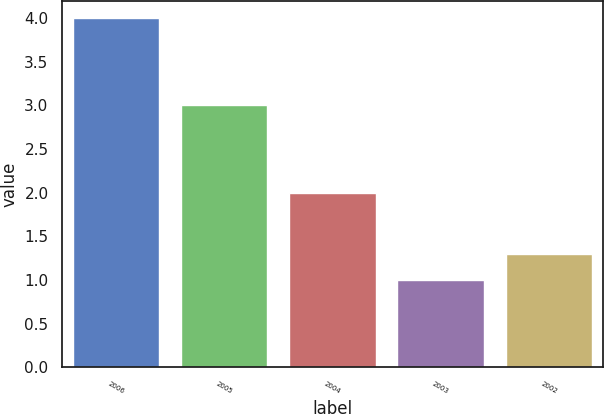Convert chart. <chart><loc_0><loc_0><loc_500><loc_500><bar_chart><fcel>2006<fcel>2005<fcel>2004<fcel>2003<fcel>2002<nl><fcel>4<fcel>3<fcel>2<fcel>1<fcel>1.3<nl></chart> 